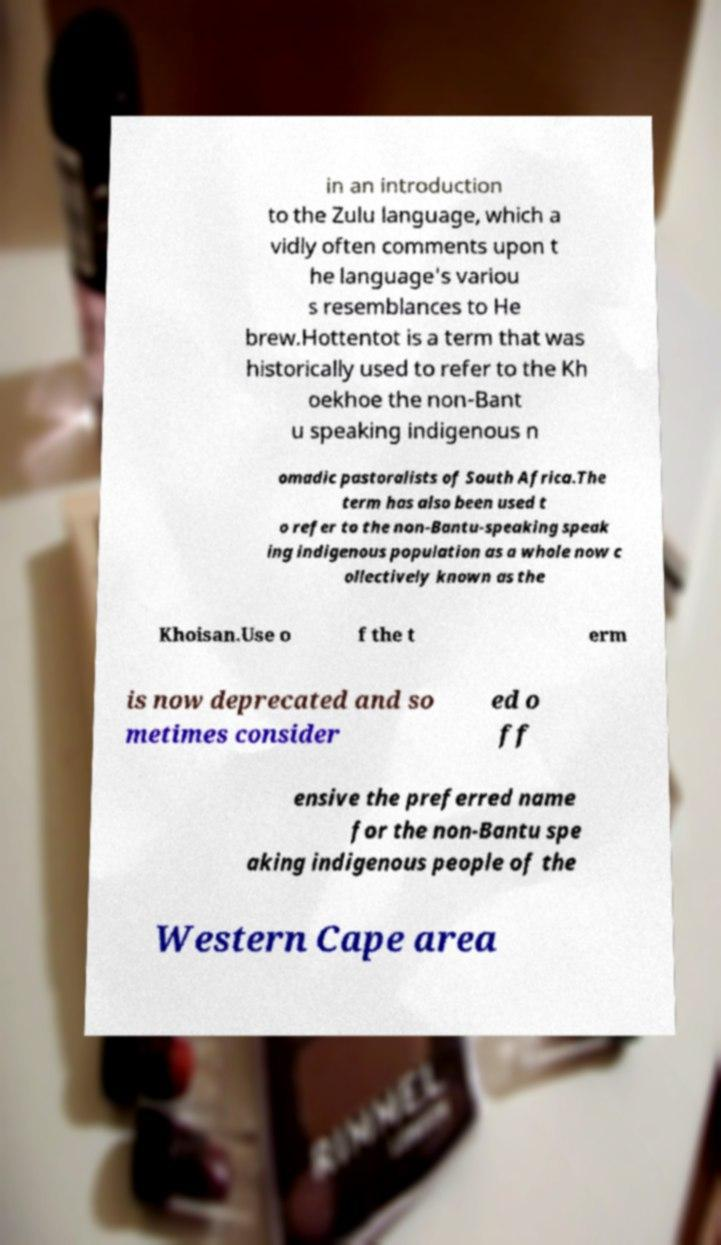Could you assist in decoding the text presented in this image and type it out clearly? in an introduction to the Zulu language, which a vidly often comments upon t he language's variou s resemblances to He brew.Hottentot is a term that was historically used to refer to the Kh oekhoe the non-Bant u speaking indigenous n omadic pastoralists of South Africa.The term has also been used t o refer to the non-Bantu-speaking speak ing indigenous population as a whole now c ollectively known as the Khoisan.Use o f the t erm is now deprecated and so metimes consider ed o ff ensive the preferred name for the non-Bantu spe aking indigenous people of the Western Cape area 